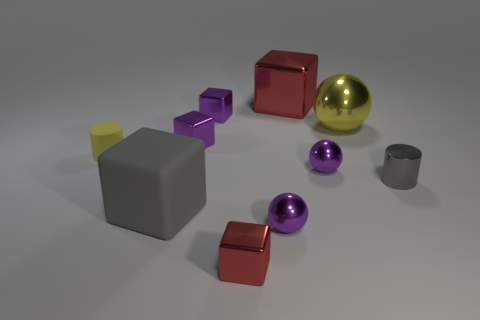The block that is behind the tiny metal object behind the purple block in front of the yellow metallic object is what color?
Offer a very short reply. Red. What is the size of the purple object that is behind the small gray shiny cylinder and right of the tiny red cube?
Your answer should be compact. Small. What number of other things are there of the same shape as the gray metallic object?
Provide a succinct answer. 1. What number of blocks are either large rubber objects or purple shiny objects?
Make the answer very short. 3. There is a purple metallic thing that is in front of the gray cube that is right of the matte cylinder; is there a tiny purple object in front of it?
Keep it short and to the point. No. The other large object that is the same shape as the big red thing is what color?
Your answer should be compact. Gray. How many gray things are either small matte cylinders or cylinders?
Your response must be concise. 1. There is a cylinder that is on the left side of the gray object left of the large yellow ball; what is its material?
Ensure brevity in your answer.  Rubber. Does the tiny gray thing have the same shape as the big yellow object?
Keep it short and to the point. No. The other cylinder that is the same size as the matte cylinder is what color?
Make the answer very short. Gray. 